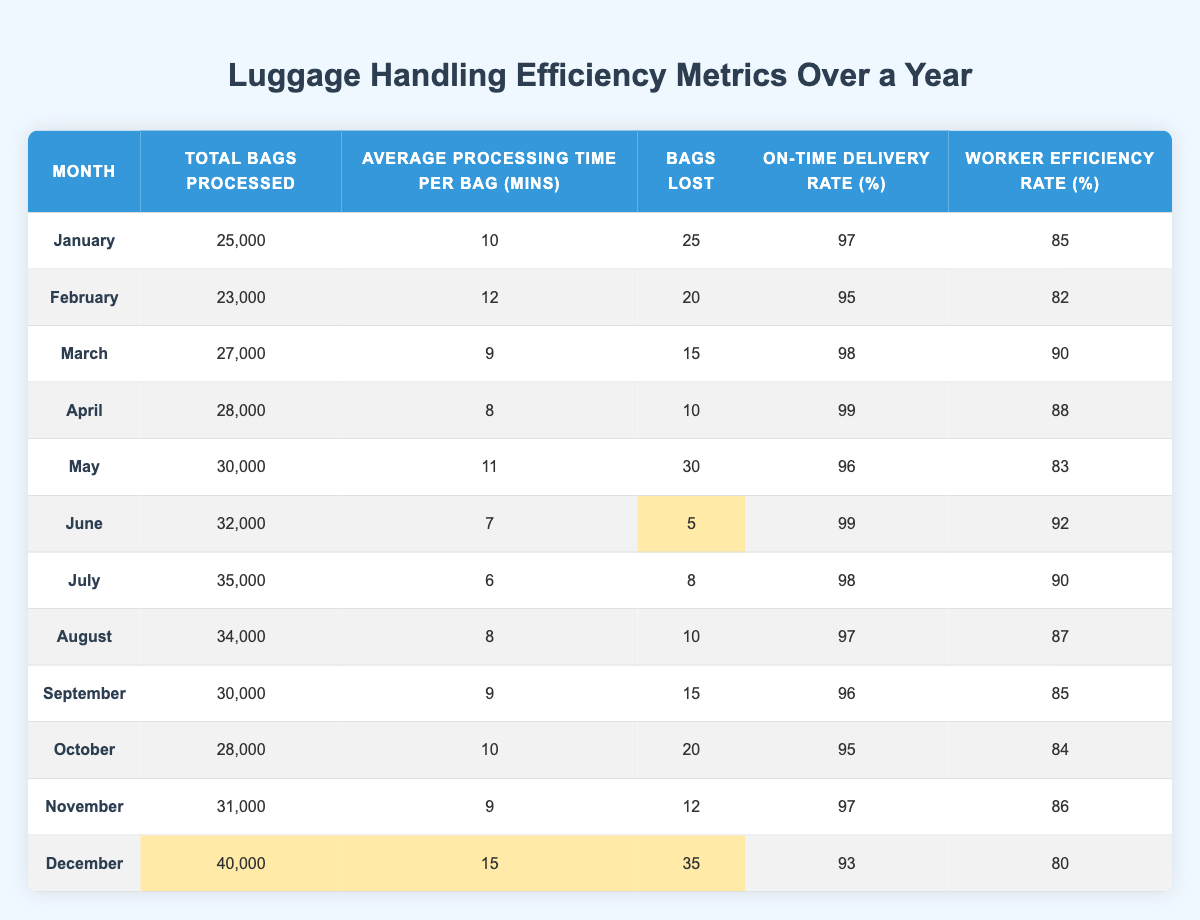What is the total number of bags processed in June? From the table, we can find the value for June under the "Total Bags Processed" column, which is 32,000.
Answer: 32,000 Which month had the highest on-time delivery rate? Looking through the "On-Time Delivery Rate (%)" column, the highest value is 99%, which occurred in April and June.
Answer: April and June How many bags were lost in December compared to March? The "Bags Lost" for December is 35, and for March, it is 15. The difference is 35 - 15 = 20, meaning 20 more bags were lost in December than in March.
Answer: 20 What is the average processing time per bag for the first half of the year (January to June)? We sum the "Average Processing Time Per Bag (mins)" for the months from January to June: (10 + 12 + 9 + 8 + 11 + 7) = 57. There are 6 months, so the average is 57 / 6 = 9.5.
Answer: 9.5 Is the worker efficiency rate in August greater than the worker efficiency rate in December? The worker efficiency rate in August is 87%, while in December it is 80%. Since 87% is greater than 80%, the statement is true.
Answer: Yes During which month was the average processing time the least? By examining the "Average Processing Time Per Bag (mins)" column, the least value is 6 minutes, which occurred in July.
Answer: July What percentage of bags were on-time during May and how does it compare to the rate in November? The on-time delivery rate for May is 96%, and for November, it is 97%. The comparison shows that November had a 1% higher rate than May.
Answer: November had a 1% higher rate How many bags were processed in April compared to the total number processed in the second half of the year (July to December)? April had 28,000 bags processed. In the second half, the sums of bags processed are: July (35,000) + August (34,000) + September (30,000) + October (28,000) + November (31,000) + December (40,000) = 228,000. Hence, April processed fewer bags compared to the second half.
Answer: Fewer bags in April What is the total percentage of on-time delivery for the entire year? To find the total percentage, we calculate the sum of the individual monthly rates: 97 + 95 + 98 + 99 + 96 + 99 + 98 + 97 + 96 + 95 + 97 + 93 = 1158. Dividing this sum by 12 gives us an average on-time delivery rate of 1158 / 12 = 96.5%.
Answer: 96.5% 